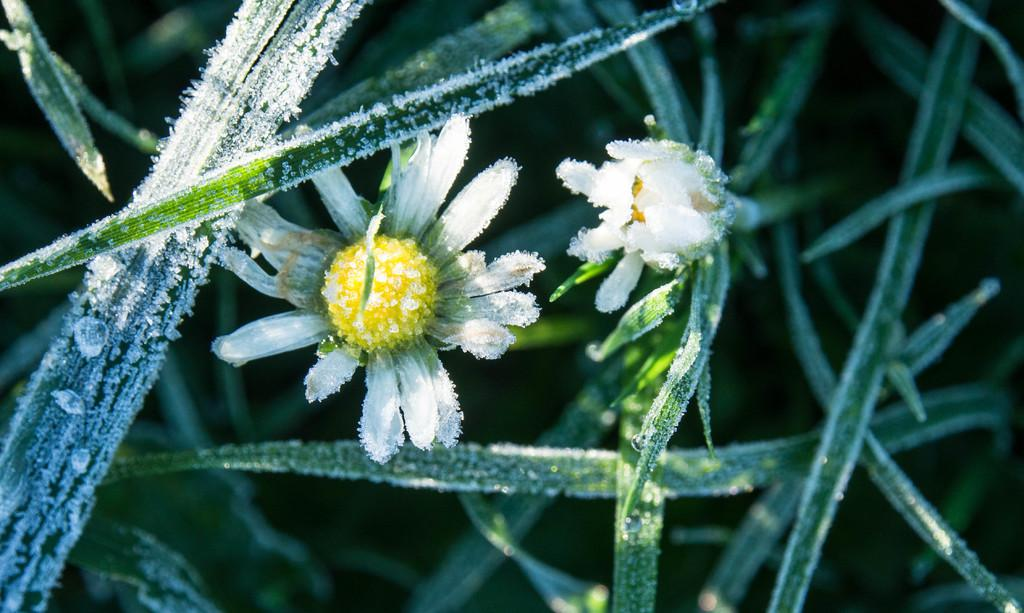What type of plants can be seen in the image? There are flowers in the image. What part of the plants can also be seen in the image? There are leaves in the image. What weather condition is depicted in the image? There is snow in the image. Can you describe the background of the image? The background of the image is blurry. What type of pets can be seen playing in the snow in the image? There are no pets present in the image; it only features flowers, leaves, and snow. What type of jam is being spread on the leaves in the image? There is no jam present in the image; it only features flowers, leaves, and snow. 